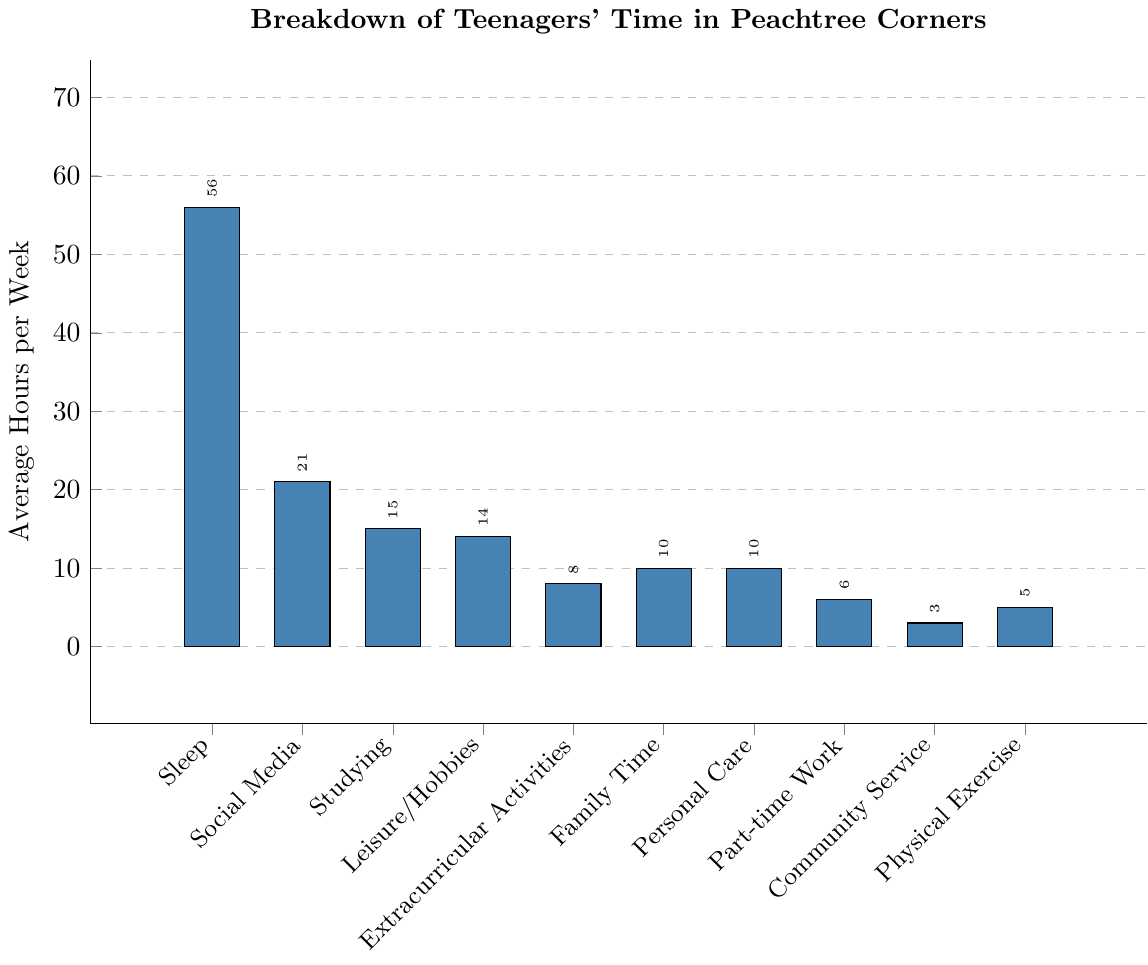What's the total time spent on studying and extracurricular activities? Add the average hours per week spent on studying (15) and extracurricular activities (8). So, 15 + 8 = 23 hours.
Answer: 23 Which activity do teenagers in Peachtree Corners spend the most time on? Find the activity with the highest average hours per week. The highest bar corresponds to Sleep, which has 56 hours.
Answer: Sleep How much more time do teenagers spend on social media compared to community service? Subtract the average hours per week spent on community service (3) from the average hours spent on social media (21). So, 21 - 3 = 18 hours.
Answer: 18 Which two activities have the same average hours per week and what is that value? Find the bars of equal height. Family Time and Personal Care both have bars at 10 hours each.
Answer: Family Time and Personal Care, 10 What's the combined total time spent on personal care, physical exercise, and community service? Add the average hours per week for personal care (10), physical exercise (5), and community service (3). So, 10 + 5 + 3 = 18 hours.
Answer: 18 By how many hours does the teenage sleep time exceed the leisure/hobbies time? Subtract the average hours per week spent on leisure/hobbies (14) from the sleep hours (56). So, 56 - 14 = 42 hours.
Answer: 42 Which activity takes up the least amount of time? Identify the shortest bar in the chart, which corresponds to Community Service at 3 hours.
Answer: Community Service Rename three activities that have the closest values in terms of average hours per week. Look for bars that are close in height. Leisure/Hobbies (14), Studying (15), and Social Media (21) are close in height.
Answer: Leisure/Hobbies, Studying, Social Media What's the average time spent on studying, social media, and part-time work? Add the average hours per week for studying (15), social media (21), and part-time work (6), then divide by 3. (15 + 21 + 6) / 3 = 42 / 3 = 14 hours.
Answer: 14 By how much does family time and physical exercise time together fall short of sleep time? Add the average hours per week for family time (10) and physical exercise (5). Subtract this sum from sleep hours (56). So, 56 - (10 + 5) = 56 - 15 = 41 hours.
Answer: 41 